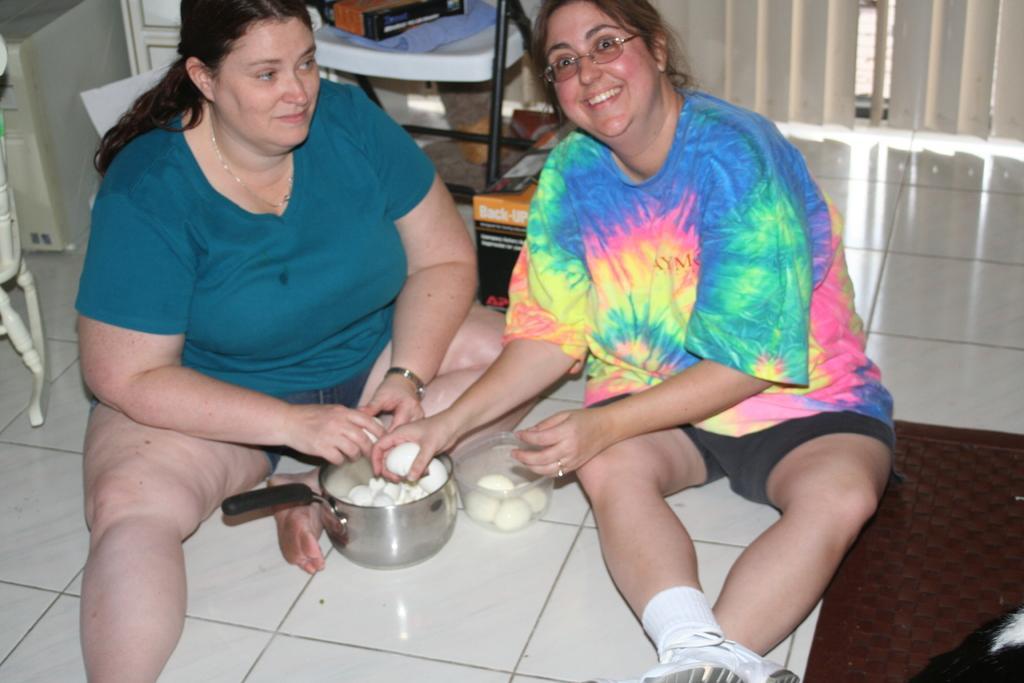Describe this image in one or two sentences. In this image in the center there are women sitting on the floor and smiling. On the left side there is an object which is white in colour. In the background there is a chair and on the chair there are objects. On the right side there is a mat which is red in colour on the floor and on the mat there is an object which is black and white in colour. In the center there are eggs in a container and there are objects which is white in colour and in the hands of the women and there is a utensil which is silver in colour and handle which is black in colour and there is a curtain in the background which is white in colour. 